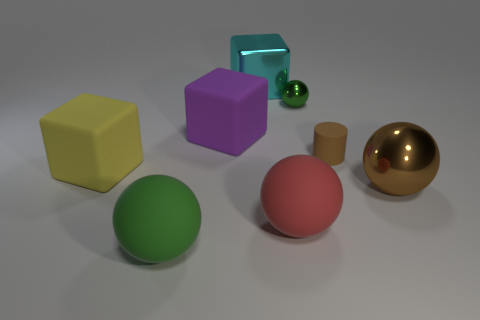Are there the same number of large yellow objects that are behind the shiny cube and large purple things?
Your response must be concise. No. What number of objects are behind the brown shiny object and right of the purple matte thing?
Your answer should be very brief. 3. There is a red ball that is the same material as the purple block; what is its size?
Your response must be concise. Large. What number of other big cyan metal objects are the same shape as the big cyan object?
Offer a very short reply. 0. Are there more red things behind the tiny brown thing than brown matte objects?
Offer a terse response. No. The big matte object that is both behind the big red ball and in front of the purple object has what shape?
Make the answer very short. Cube. Do the brown shiny thing and the yellow object have the same size?
Provide a short and direct response. Yes. There is a big red object; how many yellow blocks are left of it?
Offer a very short reply. 1. Is the number of small green things that are behind the cyan metal cube the same as the number of big brown balls to the right of the brown shiny ball?
Keep it short and to the point. Yes. Do the rubber object that is to the right of the big red matte sphere and the large green object have the same shape?
Make the answer very short. No. 